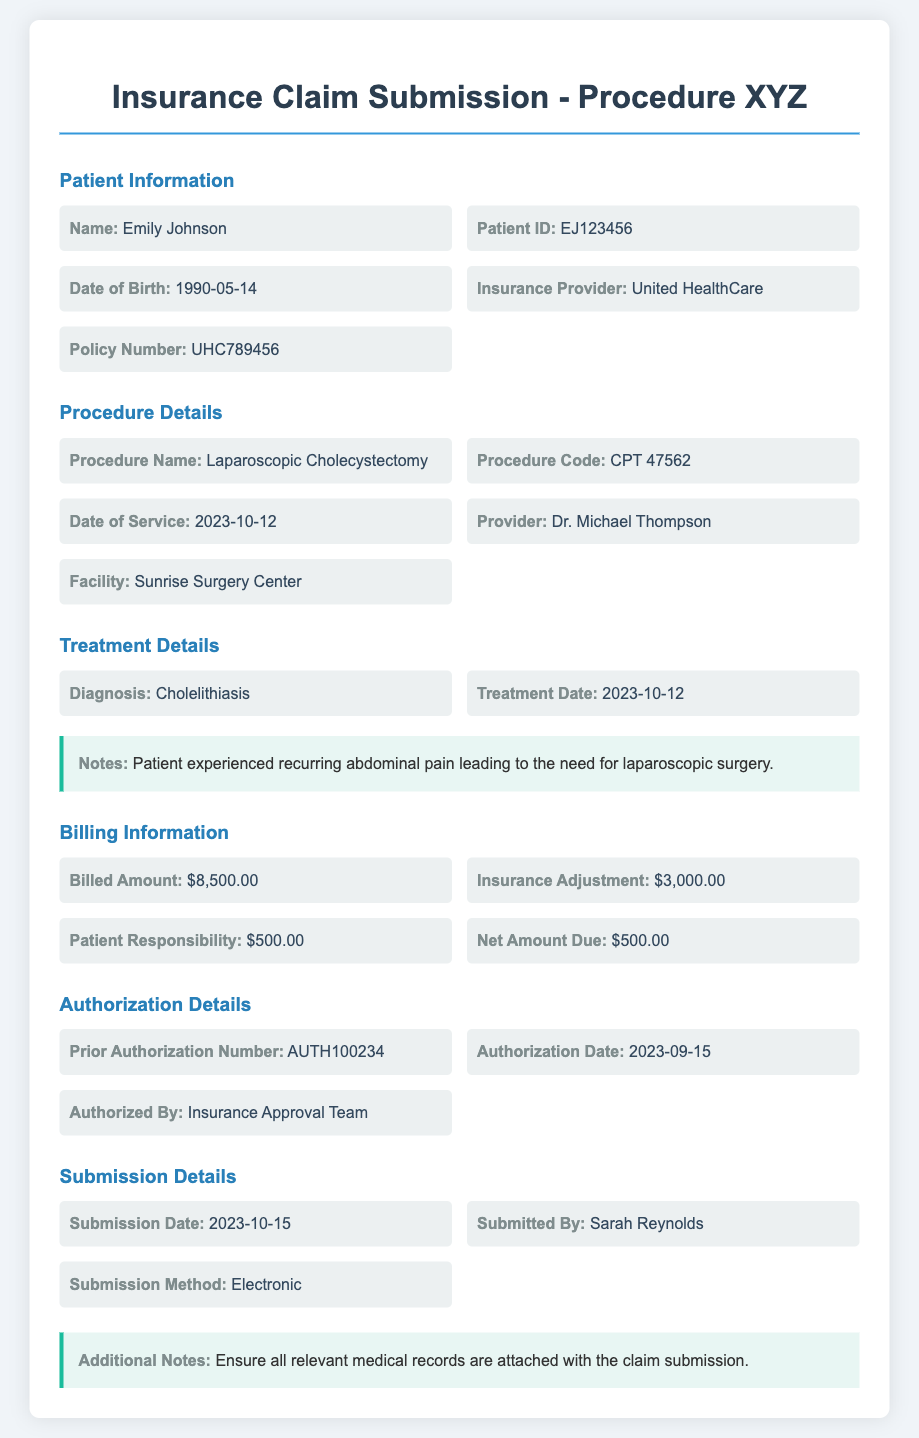What is the patient's name? The patient's name is listed at the top of the Patient Information section.
Answer: Emily Johnson What is the procedure code for Procedure XYZ? The procedure code can be found in the Procedure Details section.
Answer: CPT 47562 What is the billed amount for the treatment? The billed amount is mentioned in the Billing Information section of the document.
Answer: $8,500.00 What date was the treatment provided? The treatment date is mentioned under Treatment Details.
Answer: 2023-10-12 Who submitted the claim? The name of the individual who submitted the claim is listed in the Submission Details section.
Answer: Sarah Reynolds What is the insurance provider's name? The name of the insurance provider is indicated in the Patient Information section.
Answer: United HealthCare What is the patient’s responsibility amount? This amount is detailed in the Billing Information section.
Answer: $500.00 What is the authorization date? The authorization date is found in the Authorization Details section.
Answer: 2023-09-15 How was the claim submitted? The method of submission is specified in the Submission Details section.
Answer: Electronic 